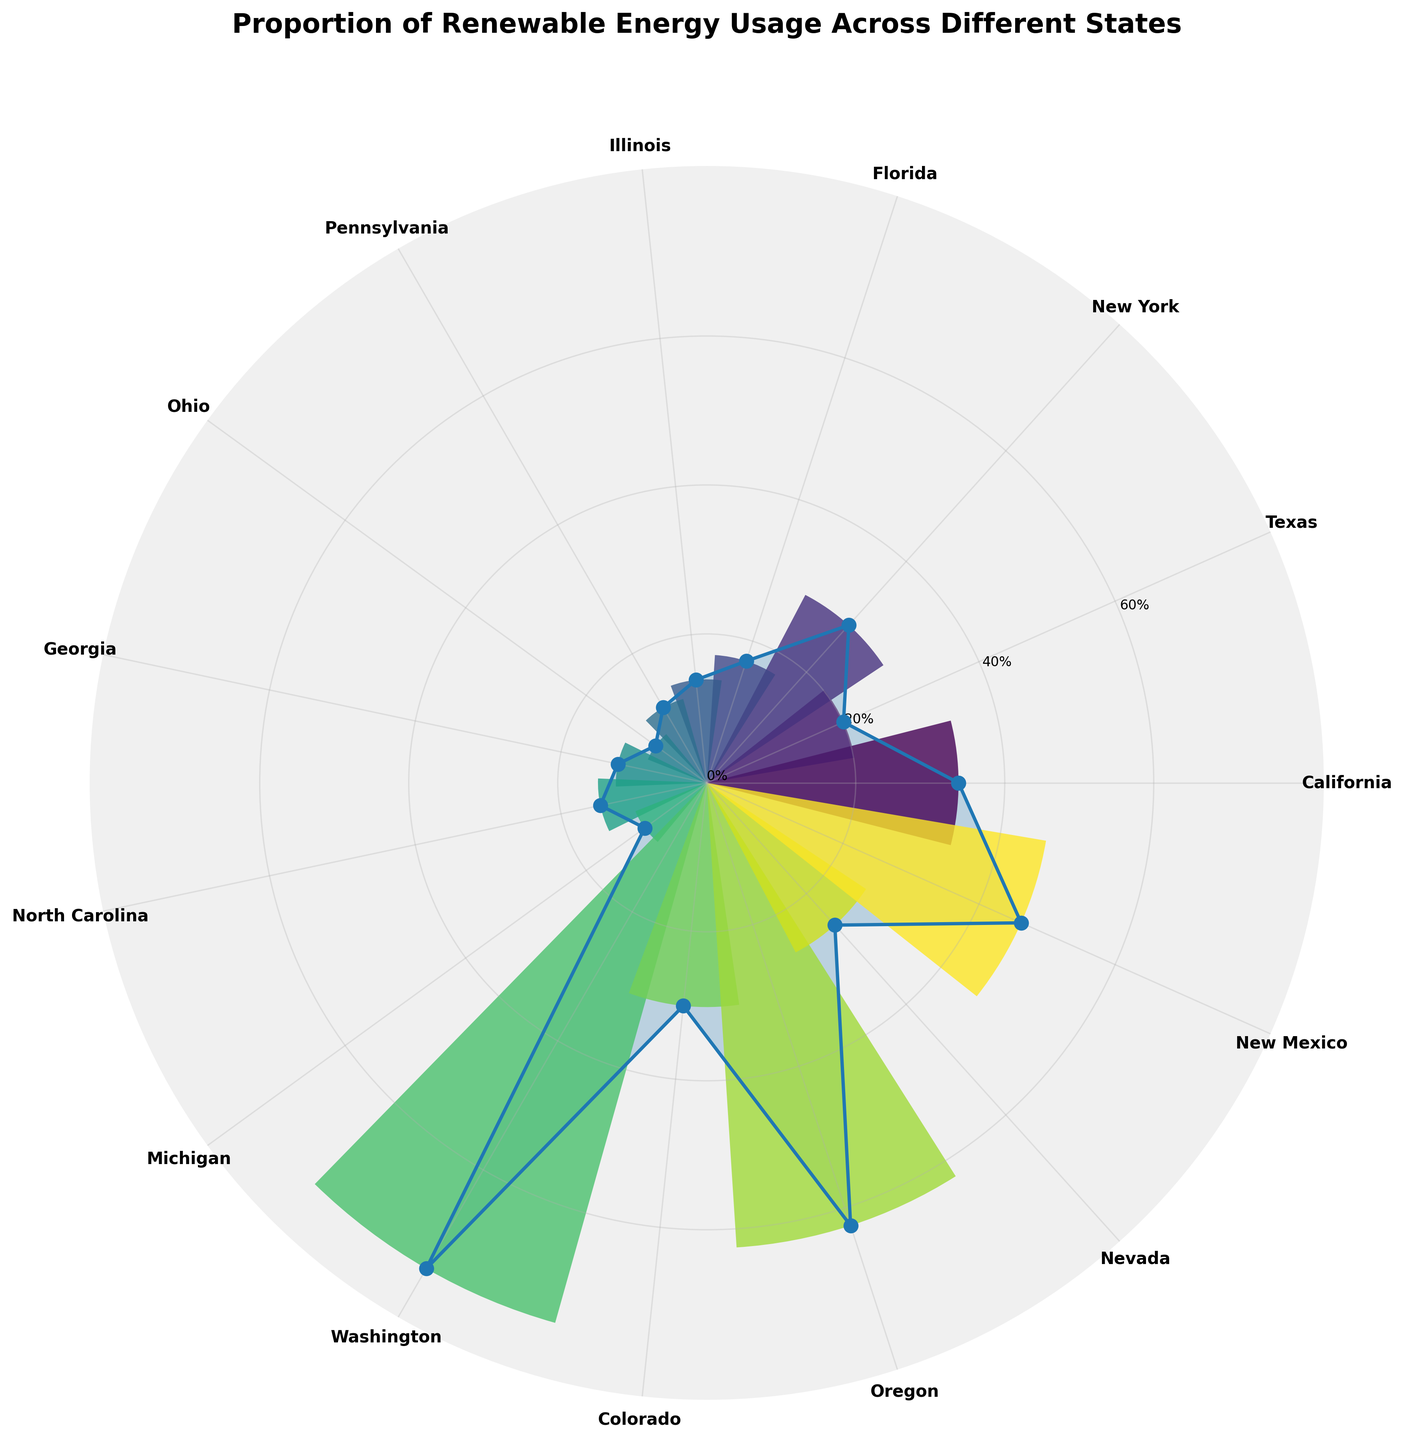What's the title of the chart? The title of the chart is usually positioned at the top of the figure. In this case, the title is given as "Proportion of Renewable Energy Usage Across Different States".
Answer: Proportion of Renewable Energy Usage Across Different States Which state has the highest proportion of renewable energy usage? To determine the state with the highest renewable energy proportion, look for the data point that reaches the furthest from the center. Here, Washington is evidently the highest.
Answer: Washington How many states have a proportion of renewable energy usage less than 15%? Identify the states whose data points fall within the radial distance representing less than 15%. Ohio, Pennsylvania, and Illinois meet this condition.
Answer: 3 What is the approximate average proportion of renewable energy usage among the states? To find the average, sum all the proportions, and then divide by the number of states. Calculate (33.8 + 20.1 + 28.5 + 17.2 + 13.9 + 11.7 + 8.5 + 12.2 + 14.6 + 10.3 + 75.3 + 30.1 + 62.5 + 25.7 + 46.2) and divide by 15. This sums to 410.6; hence, the average is 410.6/15 = 27.37%.
Answer: 27.37% Which state has a slightly higher renewable energy proportion than Florida? Compare Florida’s proportion (17.2%) with the data points around it. Georgia, with 17.7%, is slightly higher.
Answer: Georgia Which states' renewable energy usage are above 50%? Look at the radial distances and identify points above the 50% ring. Washington and Oregon exceed this threshold.
Answer: Washington, Oregon What is the difference in renewable energy proportion between Oregon and California? Look at the proportions for Oregon (62.5%) and California (33.8%). The difference is 62.5 - 33.8.
Answer: 28.7% Which state has nearly half the renewable energy proportion compared to New Mexico? Find half of New Mexico's proportion (46.2%), which is 23.1%. Nevada, with 25.7%, is the closest.
Answer: Nevada Is the renewable energy usage for Texas higher than the median state's usage? To determine the median, sort the proportions and find the middle value. Sorted, the median is the 8th value in the list: (8.5, 10.3, 11.7, 12.2, 13.9, 14.6, 17.2, 20.1, 25.7, 28.5, 30.1, 33.8, 46.2, 62.5, 75.3). Texas (20.1) is higher than the median (20.1).
Answer: Yes How many states have renewable energy usage over 30%? Count the states with data points radiating beyond the 30% boundary. California, New York, Washington, Colorado, Oregon, Nevada, New Mexico make seven states.
Answer: 7 